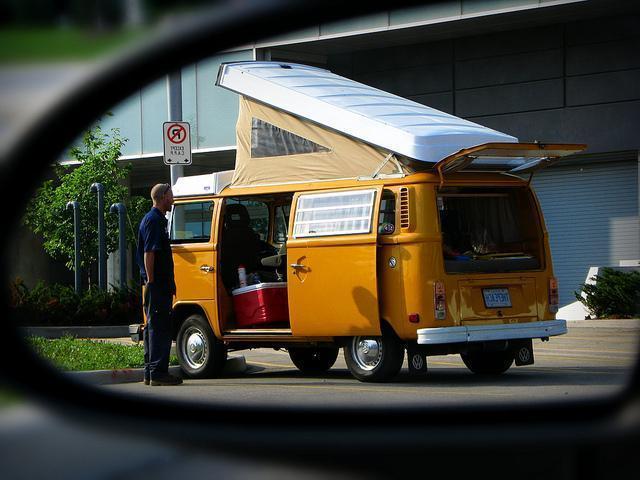How many tires does the vehicle have?
Give a very brief answer. 4. How many suitcases are there?
Give a very brief answer. 1. 